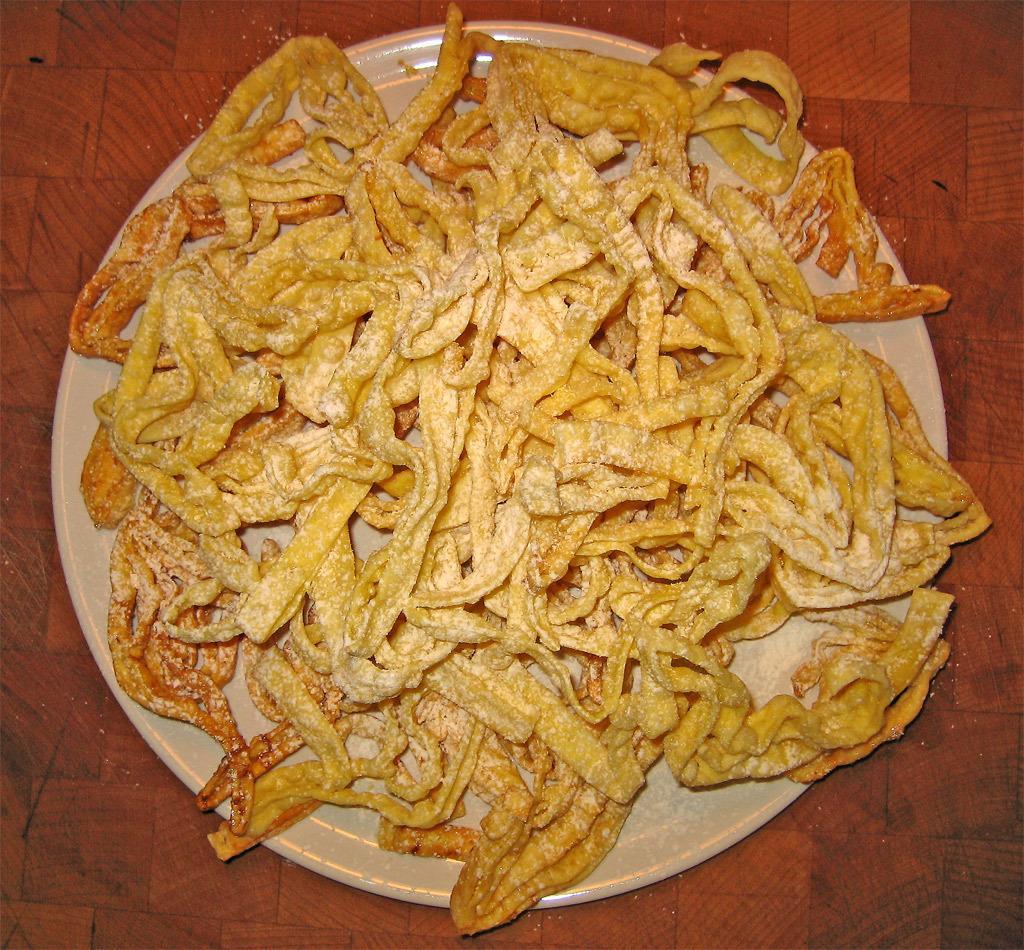Could you give a brief overview of what you see in this image? In this image there are food items in a plate which was placed on the floor. 